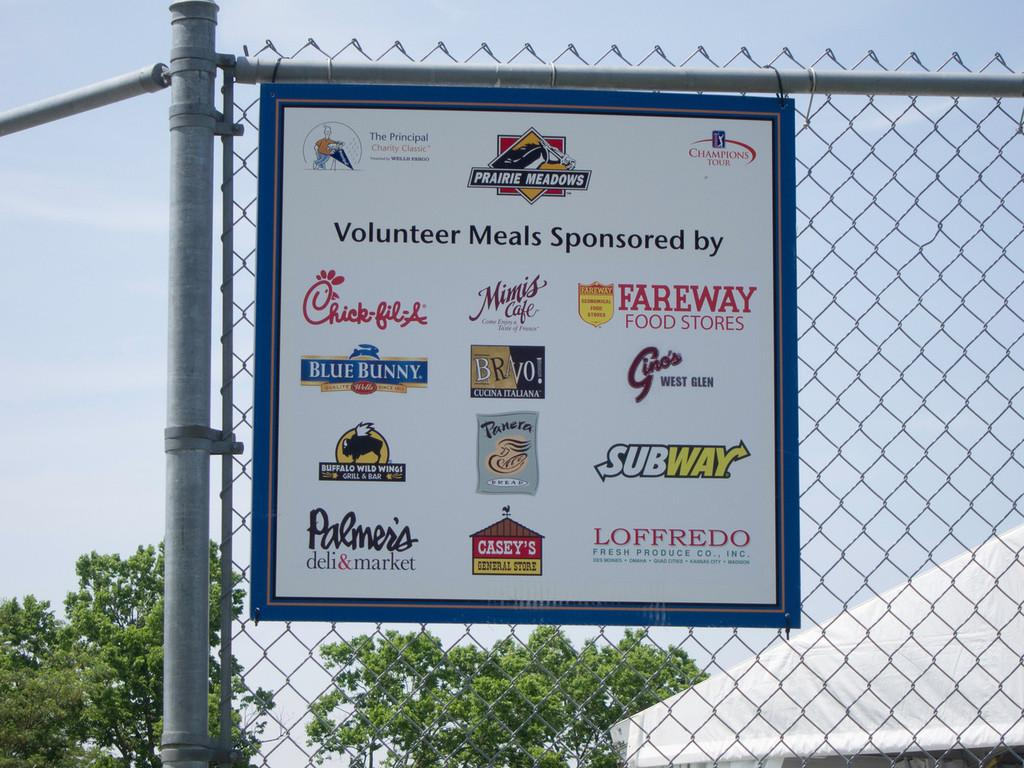<image>
Describe the image concisely. A sign hanging on a fence shows sponsors of volunteer meals for an event. 